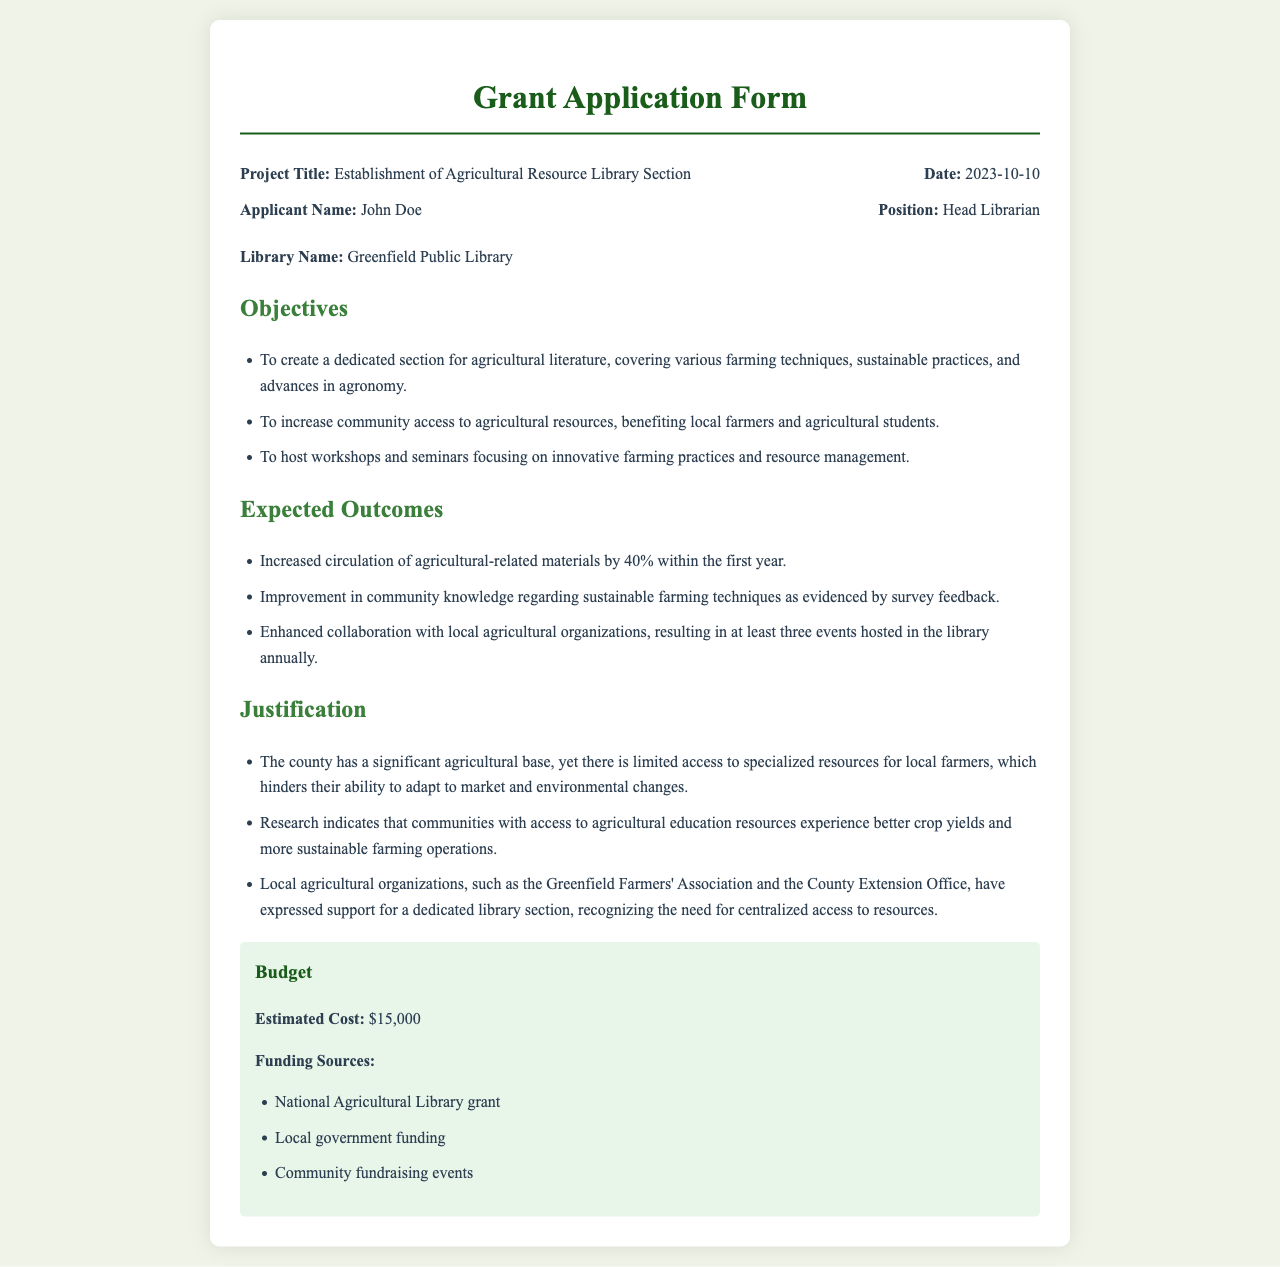What is the project title? The project title is listed at the beginning of the document, stating the purpose of the grant application.
Answer: Establishment of Agricultural Resource Library Section Who is the applicant? The applicant's name is provided under the applicant's details, identifying the individual responsible for the application.
Answer: John Doe What is the estimated cost of the project? The estimated cost is mentioned in the budget section, outlining the financial requirement for the project.
Answer: $15,000 What percentage increase in circulation is expected within the first year? The expected outcomes note this specific percentage related to the circulation of materials.
Answer: 40% What are two key objectives of the project? The objectives section provides multiple goals, allowing for the identification of key objectives related to agricultural literature and community access.
Answer: Create a dedicated section for agricultural literature, increase community access to agricultural resources What justification is given for establishing the library section? The justification section outlines reasons for the need of the library section, reflecting community challenges and support.
Answer: Limited access to specialized resources for local farmers How many events are anticipated to be hosted annually? The expected outcomes mention a collaboration that results in a specific number of hosted events per year.
Answer: Three events Which library is applying for the grant? The library name is included in the document, indicating where the new section will be established.
Answer: Greenfield Public Library What type of resources does the library section aim to cover? The objectives elaborate on the types of literature and resources intended for inclusion in the new section.
Answer: Farming techniques, sustainable practices, and advances in agronomy 